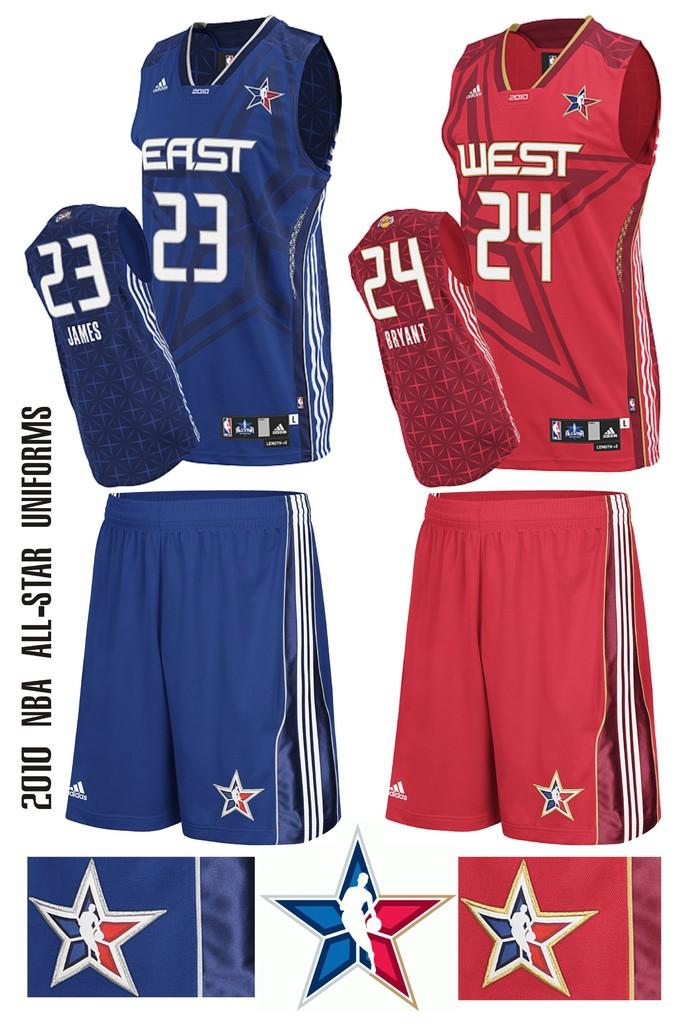<image>
Write a terse but informative summary of the picture. a west jersy for sale with the number 24 